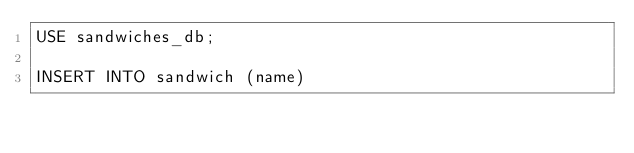<code> <loc_0><loc_0><loc_500><loc_500><_SQL_>USE sandwiches_db;

INSERT INTO sandwich (name)</code> 